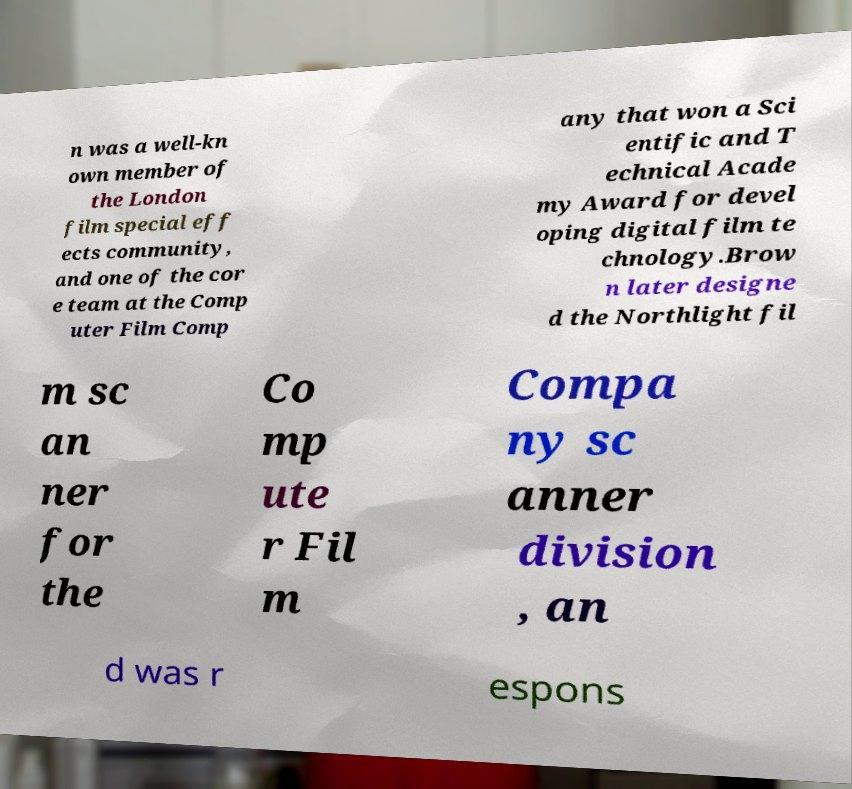There's text embedded in this image that I need extracted. Can you transcribe it verbatim? n was a well-kn own member of the London film special eff ects community, and one of the cor e team at the Comp uter Film Comp any that won a Sci entific and T echnical Acade my Award for devel oping digital film te chnology.Brow n later designe d the Northlight fil m sc an ner for the Co mp ute r Fil m Compa ny sc anner division , an d was r espons 